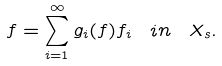<formula> <loc_0><loc_0><loc_500><loc_500>f = \sum _ { i = 1 } ^ { \infty } g _ { i } ( f ) f _ { i } \ \, i n \, \ X _ { s } .</formula> 